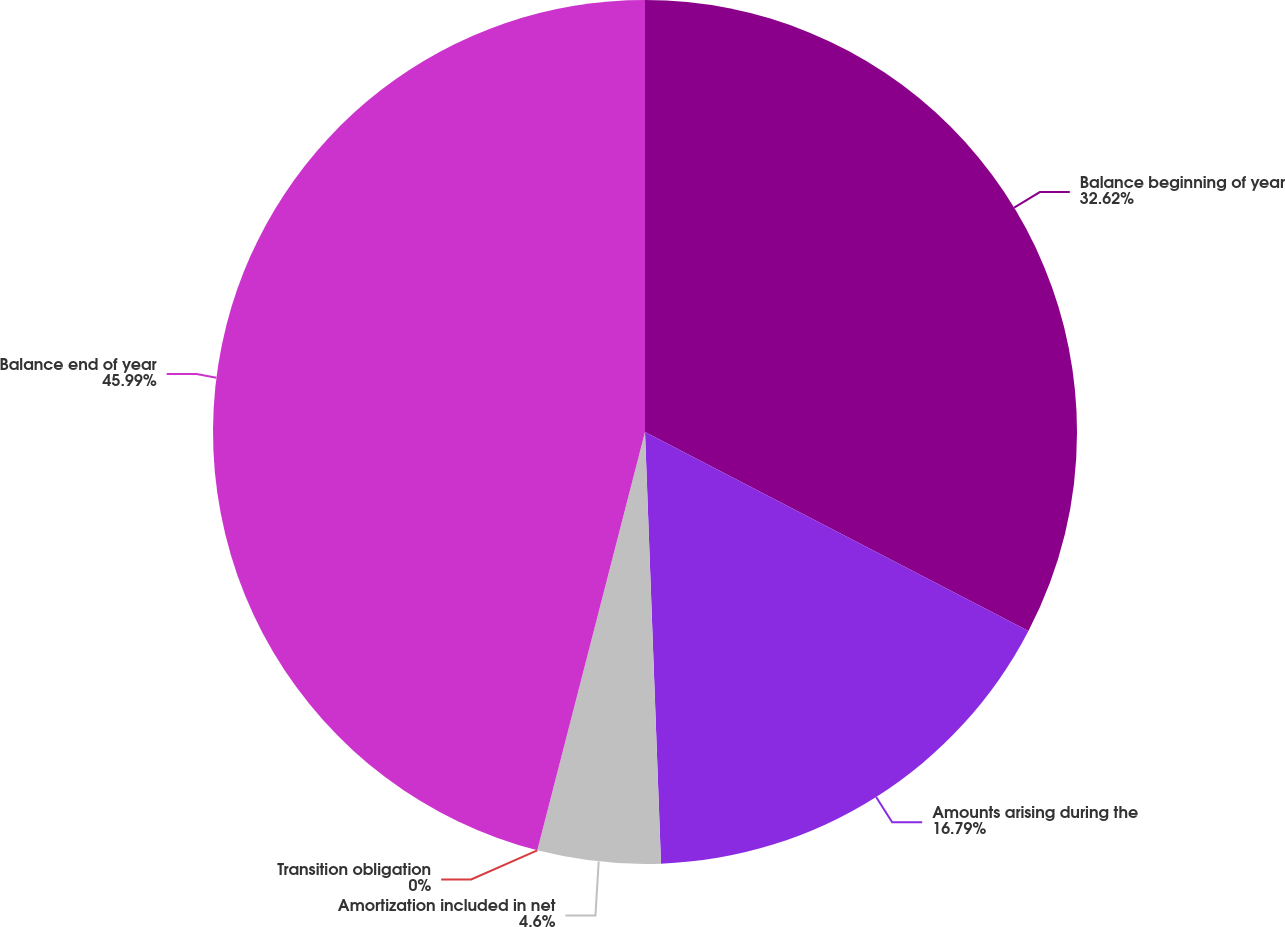Convert chart. <chart><loc_0><loc_0><loc_500><loc_500><pie_chart><fcel>Balance beginning of year<fcel>Amounts arising during the<fcel>Amortization included in net<fcel>Transition obligation<fcel>Balance end of year<nl><fcel>32.62%<fcel>16.79%<fcel>4.6%<fcel>0.0%<fcel>45.99%<nl></chart> 